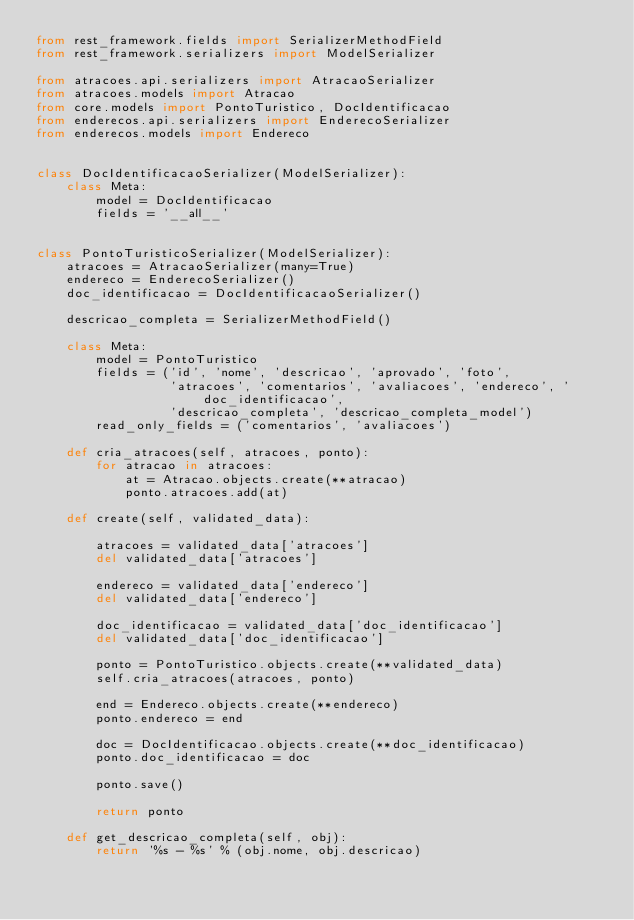<code> <loc_0><loc_0><loc_500><loc_500><_Python_>from rest_framework.fields import SerializerMethodField
from rest_framework.serializers import ModelSerializer

from atracoes.api.serializers import AtracaoSerializer
from atracoes.models import Atracao
from core.models import PontoTuristico, DocIdentificacao
from enderecos.api.serializers import EnderecoSerializer
from enderecos.models import Endereco


class DocIdentificacaoSerializer(ModelSerializer):
    class Meta:
        model = DocIdentificacao
        fields = '__all__'


class PontoTuristicoSerializer(ModelSerializer):
    atracoes = AtracaoSerializer(many=True)
    endereco = EnderecoSerializer()
    doc_identificacao = DocIdentificacaoSerializer()

    descricao_completa = SerializerMethodField()

    class Meta:
        model = PontoTuristico
        fields = ('id', 'nome', 'descricao', 'aprovado', 'foto',
                  'atracoes', 'comentarios', 'avaliacoes', 'endereco', 'doc_identificacao',
                  'descricao_completa', 'descricao_completa_model')
        read_only_fields = ('comentarios', 'avaliacoes')

    def cria_atracoes(self, atracoes, ponto):
        for atracao in atracoes:
            at = Atracao.objects.create(**atracao)
            ponto.atracoes.add(at)

    def create(self, validated_data):

        atracoes = validated_data['atracoes']
        del validated_data['atracoes']

        endereco = validated_data['endereco']
        del validated_data['endereco']

        doc_identificacao = validated_data['doc_identificacao']
        del validated_data['doc_identificacao']

        ponto = PontoTuristico.objects.create(**validated_data)
        self.cria_atracoes(atracoes, ponto)

        end = Endereco.objects.create(**endereco)
        ponto.endereco = end

        doc = DocIdentificacao.objects.create(**doc_identificacao)
        ponto.doc_identificacao = doc

        ponto.save()

        return ponto

    def get_descricao_completa(self, obj):
        return '%s - %s' % (obj.nome, obj.descricao)</code> 